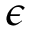<formula> <loc_0><loc_0><loc_500><loc_500>\epsilon</formula> 